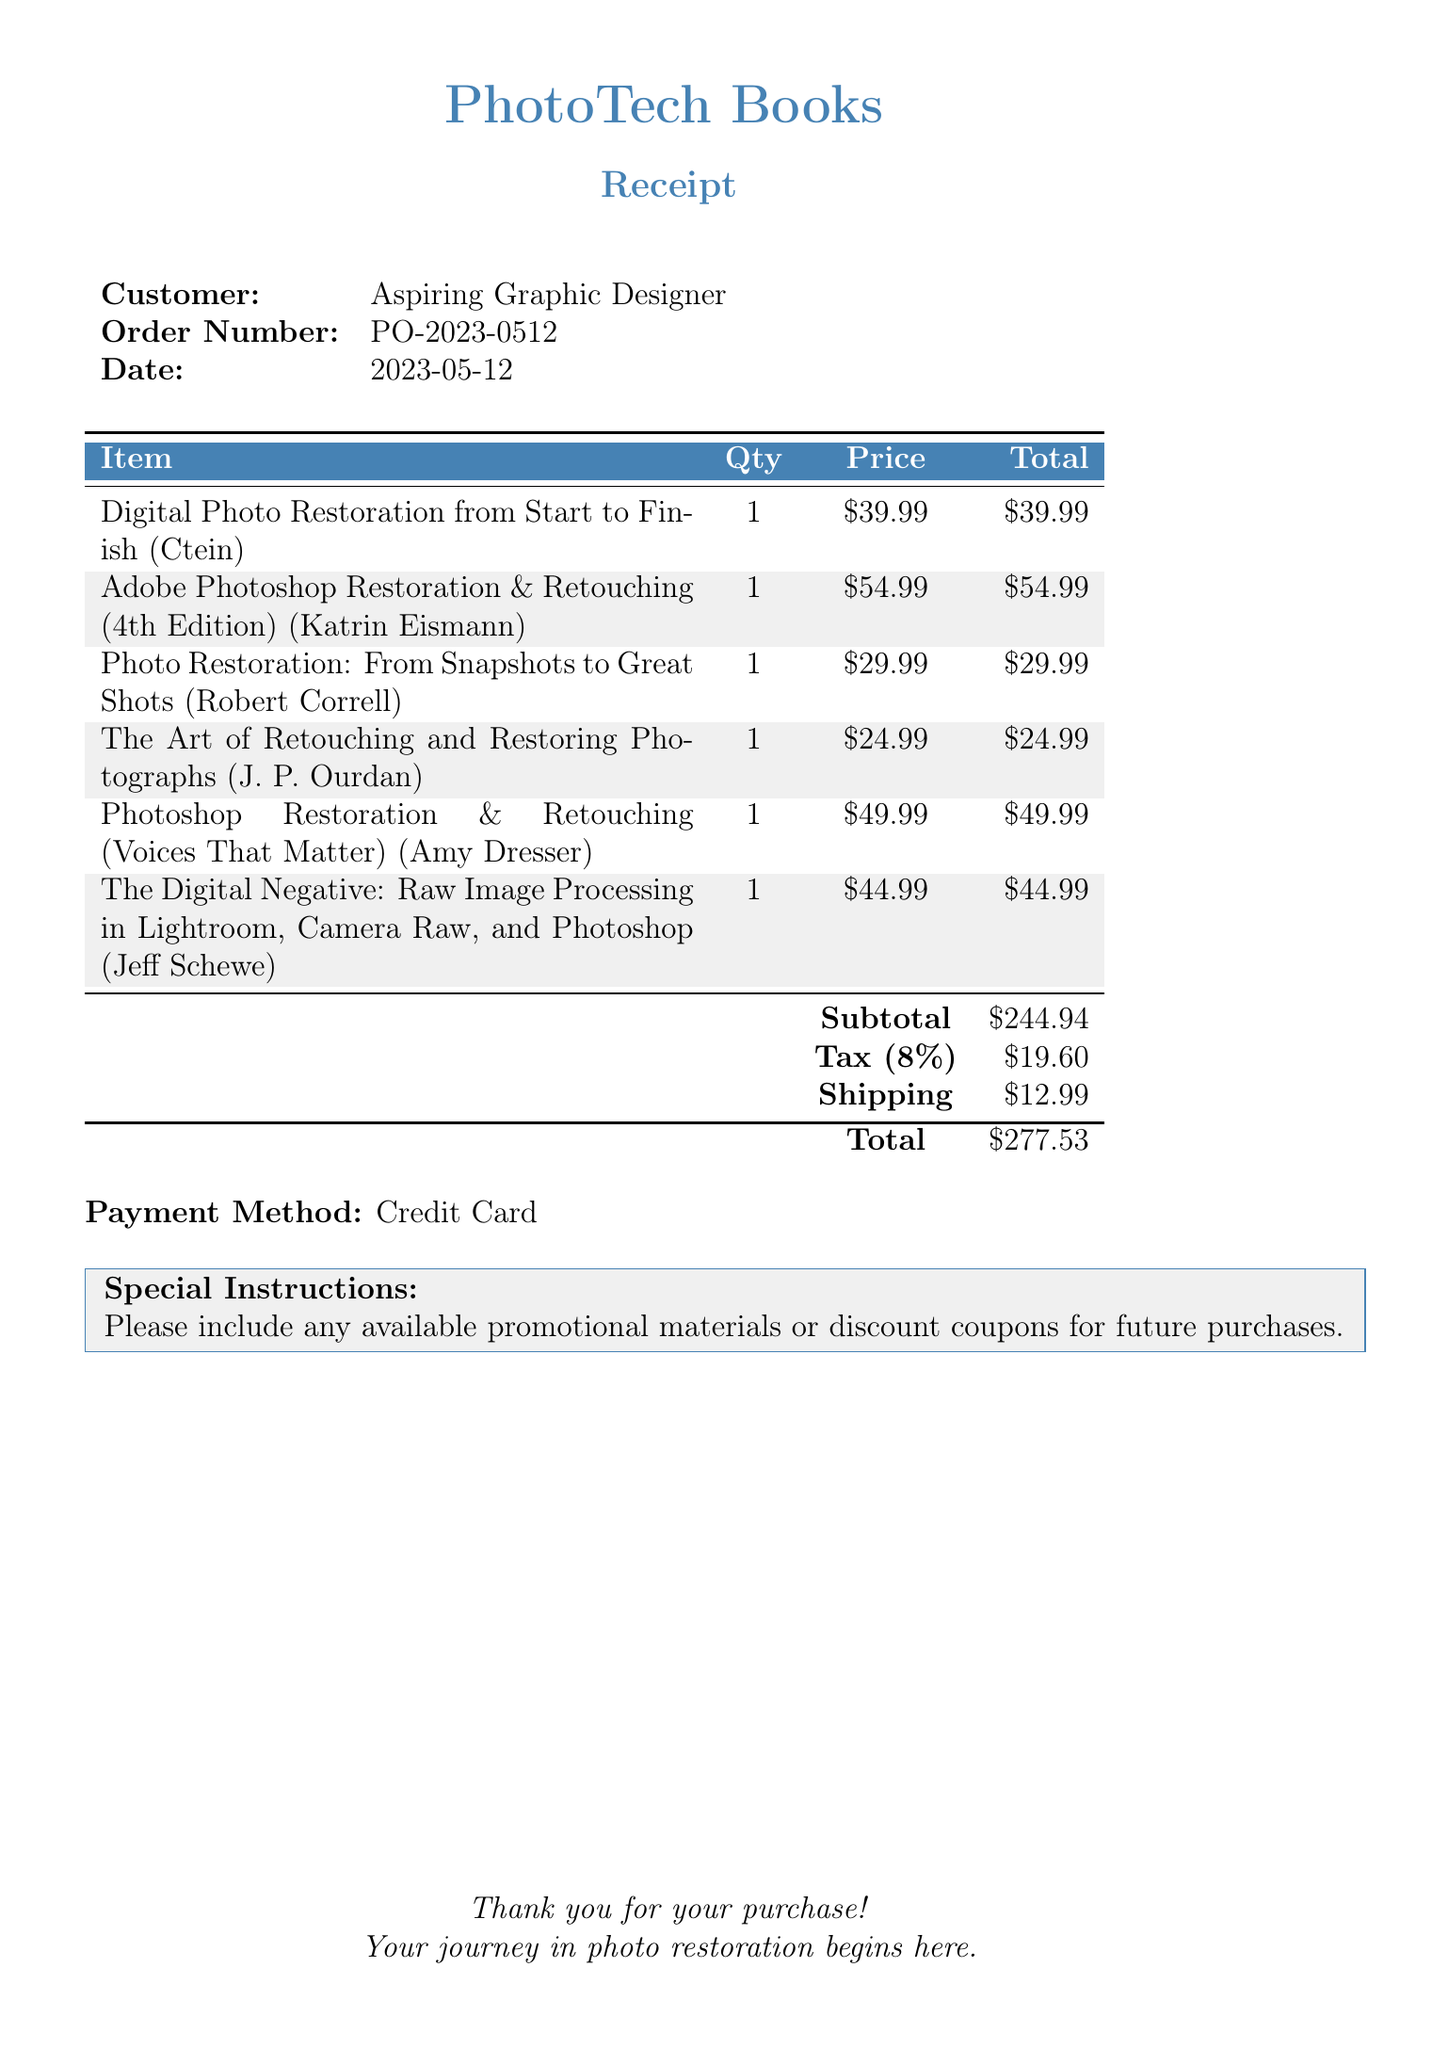What is the vendor's name? The vendor's name is listed at the top of the document and is identified as PhotoTech Books.
Answer: PhotoTech Books What is the order number? The order number is specified in the document under 'Order Number,' and it is PO-2023-0512.
Answer: PO-2023-0512 What is the date of the purchase? The date of the purchase is displayed in the document, listed as 2023-05-12.
Answer: 2023-05-12 How many items are listed in the order? The number of items can be counted from the items section in the document, which lists six books total.
Answer: 6 What is the total amount charged for the purchase? The total amount charged is indicated at the bottom of the document after adding subtotal, tax, and shipping costs, which totals to $277.53.
Answer: $277.53 Which book has the highest price? By examining the price of each book listed, the one with the highest price is Adobe Photoshop Restoration & Retouching (4th Edition) for $54.99.
Answer: Adobe Photoshop Restoration & Retouching (4th Edition) What payment method was used? The payment method is mentioned in the document, specifically stating it was made with a credit card.
Answer: Credit Card What are the special instructions noted in the receipt? The special instructions are clearly stated in the section towards the bottom of the document, requesting promotional materials or discount coupons.
Answer: Please include any available promotional materials or discount coupons for future purchases What is the tax amount calculated for the order? The tax amount is specified in the receipt and noted as $19.60.
Answer: $19.60 